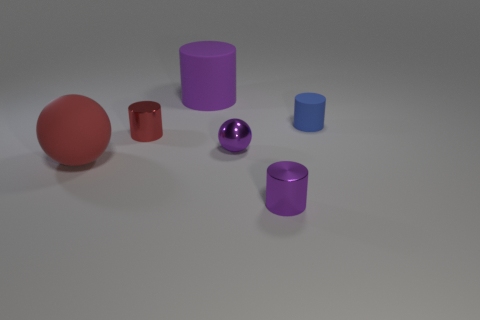Add 1 green shiny cylinders. How many objects exist? 7 Subtract all red blocks. How many red balls are left? 1 Subtract all small purple things. Subtract all red cubes. How many objects are left? 4 Add 1 red matte balls. How many red matte balls are left? 2 Add 2 large cylinders. How many large cylinders exist? 3 Subtract all purple balls. How many balls are left? 1 Subtract all tiny purple shiny cylinders. How many cylinders are left? 3 Subtract 0 gray cylinders. How many objects are left? 6 Subtract all spheres. How many objects are left? 4 Subtract 2 cylinders. How many cylinders are left? 2 